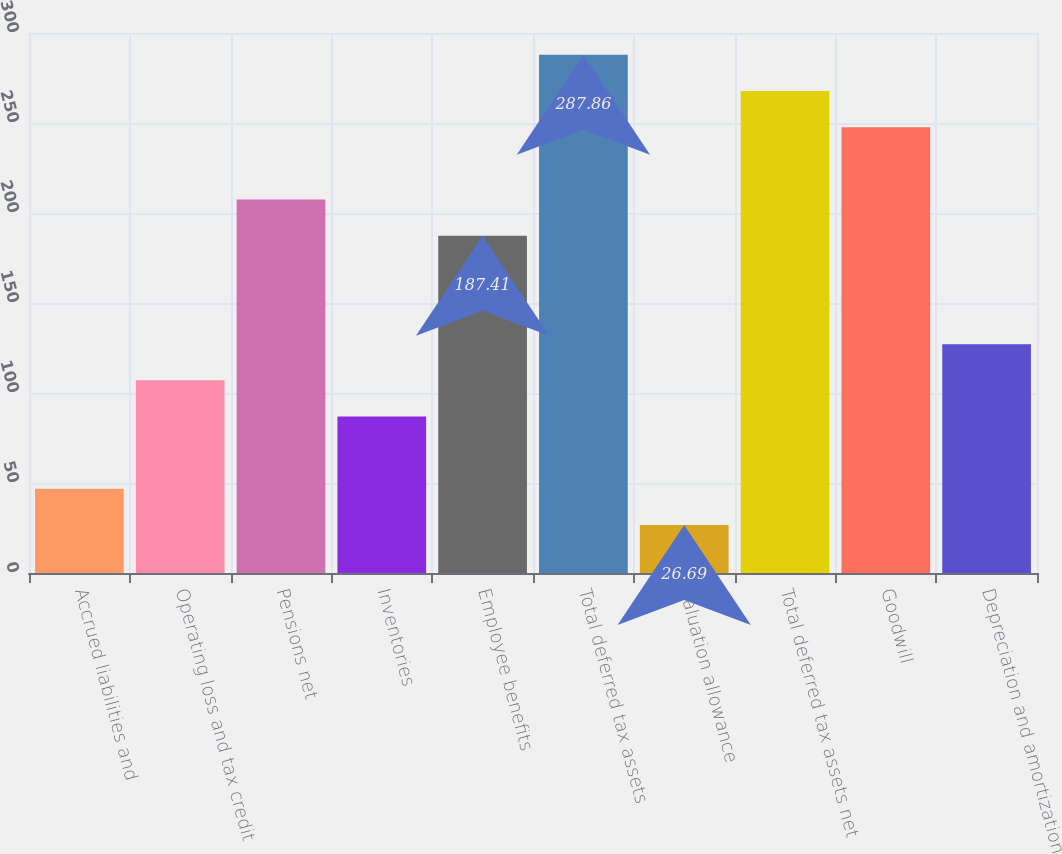Convert chart to OTSL. <chart><loc_0><loc_0><loc_500><loc_500><bar_chart><fcel>Accrued liabilities and<fcel>Operating loss and tax credit<fcel>Pensions net<fcel>Inventories<fcel>Employee benefits<fcel>Total deferred tax assets<fcel>Valuation allowance<fcel>Total deferred tax assets net<fcel>Goodwill<fcel>Depreciation and amortization<nl><fcel>46.78<fcel>107.05<fcel>207.5<fcel>86.96<fcel>187.41<fcel>287.86<fcel>26.69<fcel>267.77<fcel>247.68<fcel>127.14<nl></chart> 